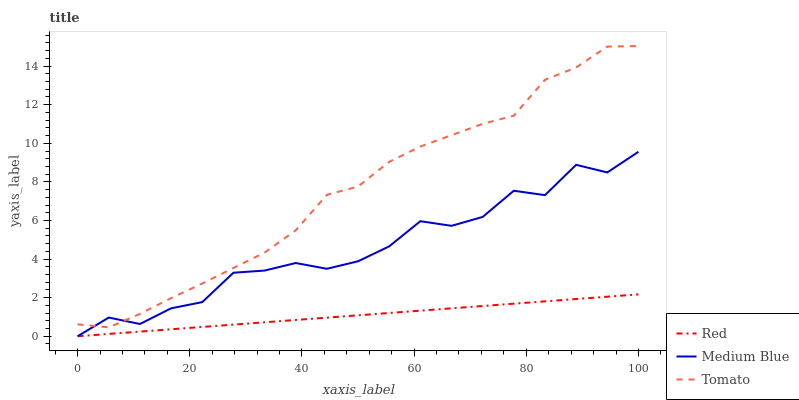Does Red have the minimum area under the curve?
Answer yes or no. Yes. Does Tomato have the maximum area under the curve?
Answer yes or no. Yes. Does Medium Blue have the minimum area under the curve?
Answer yes or no. No. Does Medium Blue have the maximum area under the curve?
Answer yes or no. No. Is Red the smoothest?
Answer yes or no. Yes. Is Medium Blue the roughest?
Answer yes or no. Yes. Is Medium Blue the smoothest?
Answer yes or no. No. Is Red the roughest?
Answer yes or no. No. Does Medium Blue have the lowest value?
Answer yes or no. Yes. Does Tomato have the highest value?
Answer yes or no. Yes. Does Medium Blue have the highest value?
Answer yes or no. No. Is Red less than Tomato?
Answer yes or no. Yes. Is Tomato greater than Red?
Answer yes or no. Yes. Does Medium Blue intersect Red?
Answer yes or no. Yes. Is Medium Blue less than Red?
Answer yes or no. No. Is Medium Blue greater than Red?
Answer yes or no. No. Does Red intersect Tomato?
Answer yes or no. No. 